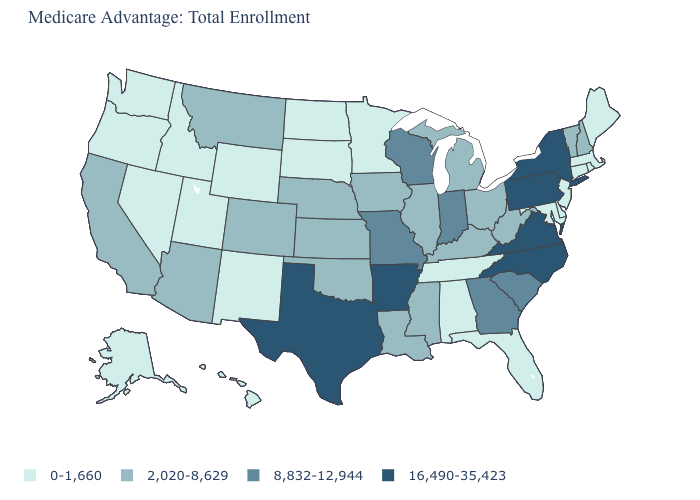What is the highest value in the South ?
Give a very brief answer. 16,490-35,423. Name the states that have a value in the range 0-1,660?
Quick response, please. Alaska, Alabama, Connecticut, Delaware, Florida, Hawaii, Idaho, Massachusetts, Maryland, Maine, Minnesota, North Dakota, New Jersey, New Mexico, Nevada, Oregon, Rhode Island, South Dakota, Tennessee, Utah, Washington, Wyoming. What is the value of California?
Write a very short answer. 2,020-8,629. What is the value of Vermont?
Quick response, please. 2,020-8,629. How many symbols are there in the legend?
Give a very brief answer. 4. Among the states that border New Mexico , does Utah have the lowest value?
Answer briefly. Yes. Among the states that border Colorado , does New Mexico have the lowest value?
Answer briefly. Yes. Does North Dakota have the lowest value in the MidWest?
Be succinct. Yes. What is the lowest value in the South?
Write a very short answer. 0-1,660. How many symbols are there in the legend?
Give a very brief answer. 4. What is the value of Arkansas?
Be succinct. 16,490-35,423. Among the states that border Nevada , does Idaho have the highest value?
Keep it brief. No. Name the states that have a value in the range 0-1,660?
Quick response, please. Alaska, Alabama, Connecticut, Delaware, Florida, Hawaii, Idaho, Massachusetts, Maryland, Maine, Minnesota, North Dakota, New Jersey, New Mexico, Nevada, Oregon, Rhode Island, South Dakota, Tennessee, Utah, Washington, Wyoming. Does Washington have the highest value in the USA?
Answer briefly. No. Among the states that border Massachusetts , does Vermont have the lowest value?
Quick response, please. No. 